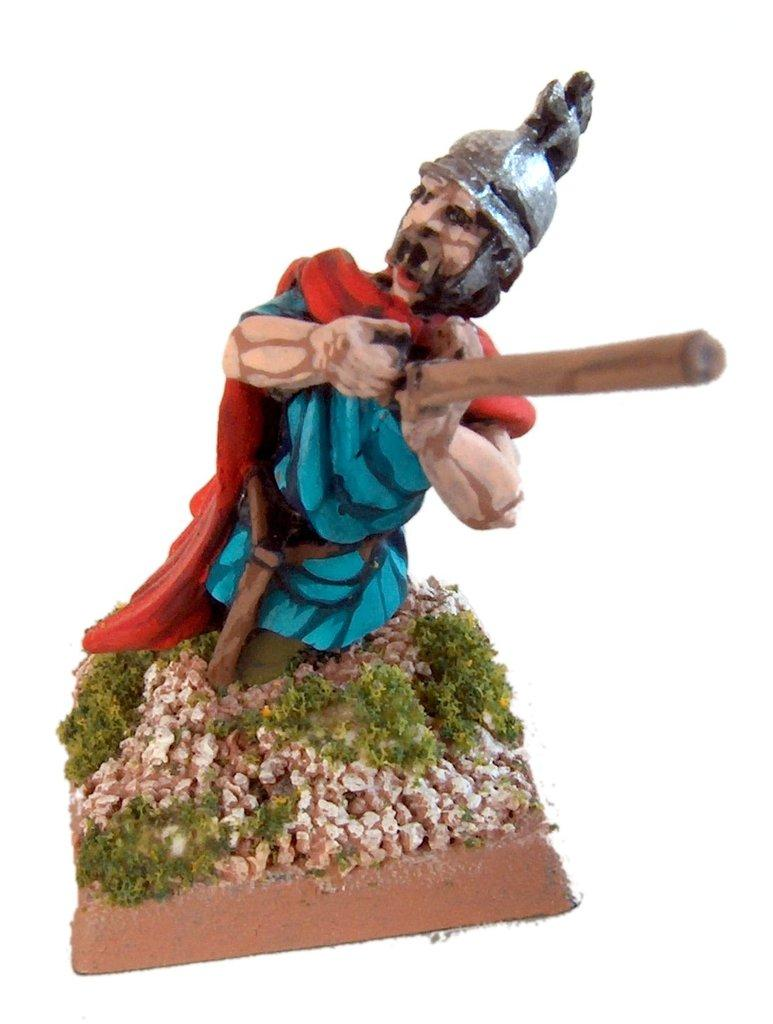What is the main subject of the image? There is a sculpture of a man in the image. Can you describe the sculpture in more detail? Unfortunately, the provided facts do not offer any additional details about the sculpture. What might be the purpose of the sculpture? The purpose of the sculpture cannot be determined from the given facts. What type of stitch is used to create the man's clothing in the sculpture? There is no information about the man's clothing or the stitch used in the sculpture, as the provided facts only mention the existence of a sculpture of a man. 